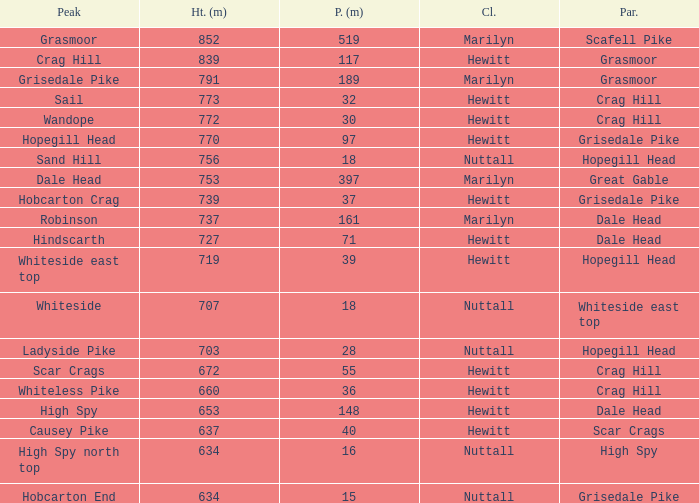Which Parent has height smaller than 756 and a Prom of 39? Hopegill Head. 